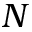<formula> <loc_0><loc_0><loc_500><loc_500>N</formula> 